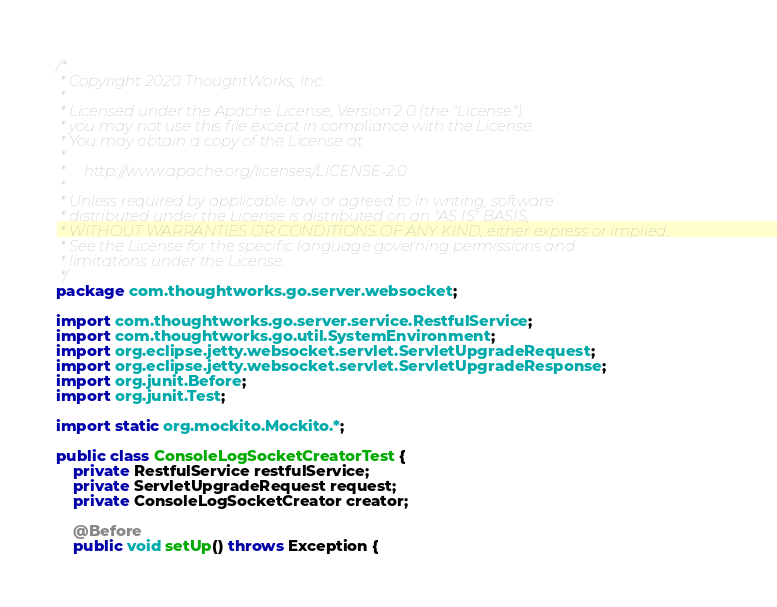Convert code to text. <code><loc_0><loc_0><loc_500><loc_500><_Java_>/*
 * Copyright 2020 ThoughtWorks, Inc.
 *
 * Licensed under the Apache License, Version 2.0 (the "License");
 * you may not use this file except in compliance with the License.
 * You may obtain a copy of the License at
 *
 *     http://www.apache.org/licenses/LICENSE-2.0
 *
 * Unless required by applicable law or agreed to in writing, software
 * distributed under the License is distributed on an "AS IS" BASIS,
 * WITHOUT WARRANTIES OR CONDITIONS OF ANY KIND, either express or implied.
 * See the License for the specific language governing permissions and
 * limitations under the License.
 */
package com.thoughtworks.go.server.websocket;

import com.thoughtworks.go.server.service.RestfulService;
import com.thoughtworks.go.util.SystemEnvironment;
import org.eclipse.jetty.websocket.servlet.ServletUpgradeRequest;
import org.eclipse.jetty.websocket.servlet.ServletUpgradeResponse;
import org.junit.Before;
import org.junit.Test;

import static org.mockito.Mockito.*;

public class ConsoleLogSocketCreatorTest {
    private RestfulService restfulService;
    private ServletUpgradeRequest request;
    private ConsoleLogSocketCreator creator;

    @Before
    public void setUp() throws Exception {</code> 